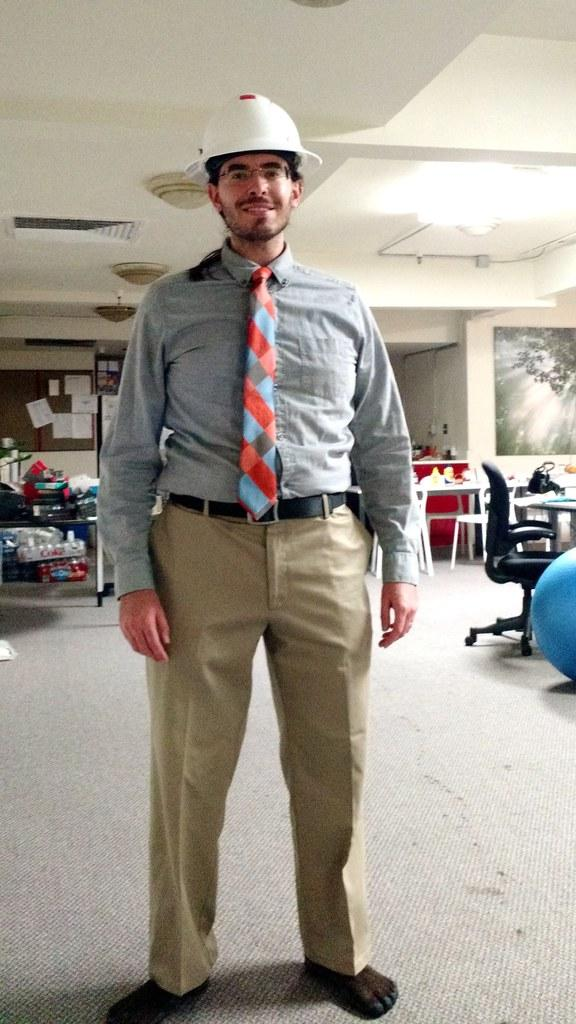Who is the main subject in the image? There is a man in the image. Where is the man positioned in the image? The man is standing in the center of the image. What objects can be seen on the right side of the image? There are chairs on the right side of the image. Can you tell me how many monkeys are sitting on the chairs in the image? There are no monkeys present in the image; it features a man standing in the center and chairs on the right side. What type of food is the cook preparing in the image? There is no cook or food preparation visible in the image. 